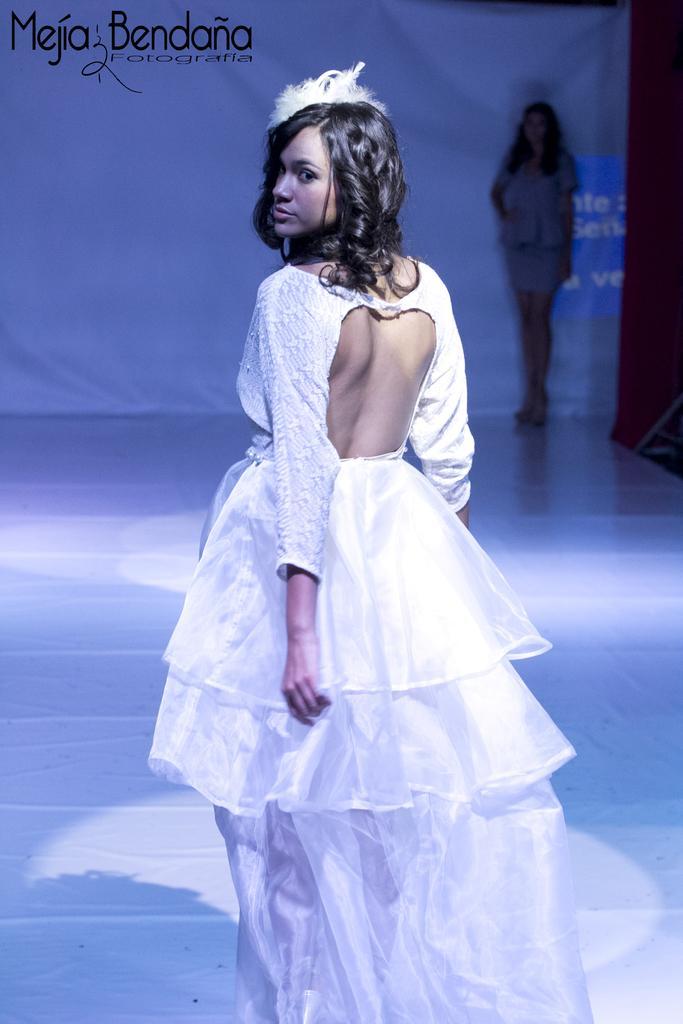Describe this image in one or two sentences. In this picture I can see two persons standing, and in the background there is a banner and there is a watermark on the image. 